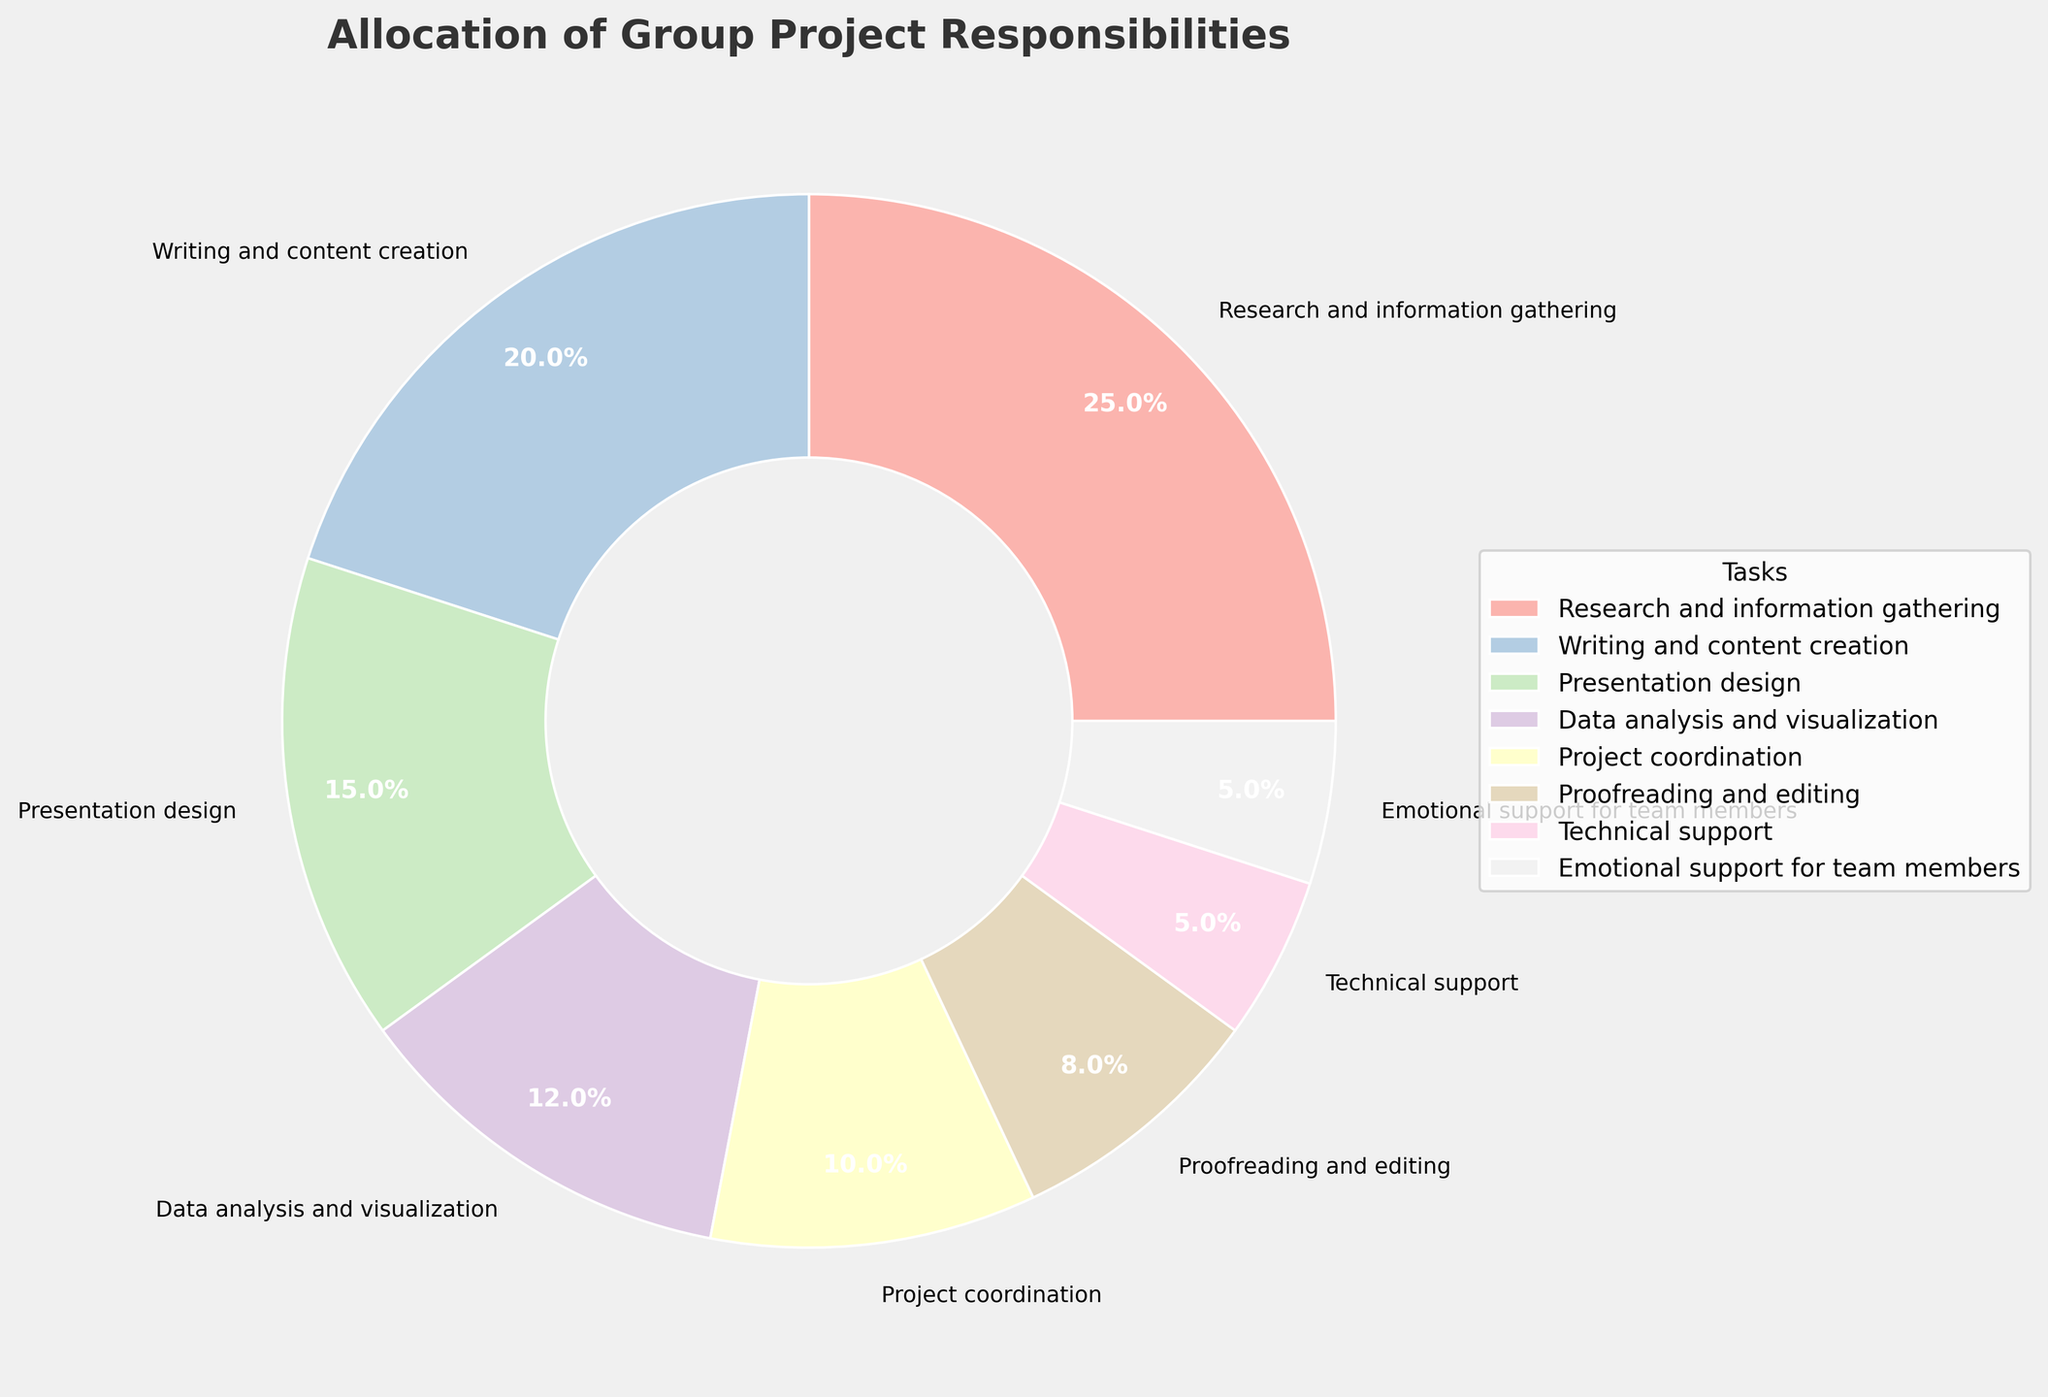What is the task with the highest percentage allocation? The task with the largest percentage in the pie chart has the biggest section. By looking at the chart, "Research and information gathering" has the largest slice.
Answer: Research and information gathering Which two tasks have the smallest percentage, and what are their values? The two tasks with the smallest slices on the pie chart represent the smallest percentages. These slices are labeled "Emotional support for team members" and "Technical support," both with 5%.
Answer: Emotional support for team members and Technical support, 5% How much more percentage is allocated to Research and information gathering compared to Project coordination? Find the percentage for both tasks from the chart, then subtract the percentage for Project coordination from the percentage for Research and information gathering: 25% - 10% = 15%.
Answer: 15% What is the combined percentage for Data analysis and visualization and Presentation design? Add the percentages of "Data analysis and visualization" and "Presentation design": 12% + 15% = 27%.
Answer: 27% How much percent more is Writing and content creation than Proofreading and editing? Subtract the percentage for Proofreading and editing from the percentage for Writing and content creation: 20% - 8% = 12%.
Answer: 12% What is the percentage allocated to tasks under 10%? Identify tasks with less than 10% and sum their percentages: Proofreading and editing (8%) + Technical support (5%) + Emotional support for team members (5%) = 18%.
Answer: 18% Compare the combined percentage of Project coordination and Technical support with the combined percentage of Data analysis and visualization and Presentation design. Which is greater? Calculate the combined percentages: Project coordination (10%) + Technical support (5%) = 15%; Data analysis and visualization (12%) + Presentation design (15%) = 27%. Compare them, 27% is greater than 15%.
Answer: Data analysis and visualization and Presentation design Which task uses a darker color in the pie chart, Proofreading and editing or Emotional support for team members? By examining the color intensity of the sections labeled "Proofreading and editing" and "Emotional support for team members" in the pastel-colored chart, "Proofreading and editing" appears to have a darker color.
Answer: Proofreading and editing What is the average percentage allocation for Presentation design, Project coordination, and Technical support? Add up the percentages and divide by the number of tasks: (15% + 10% + 5%) / 3 = 10%.
Answer: 10% 